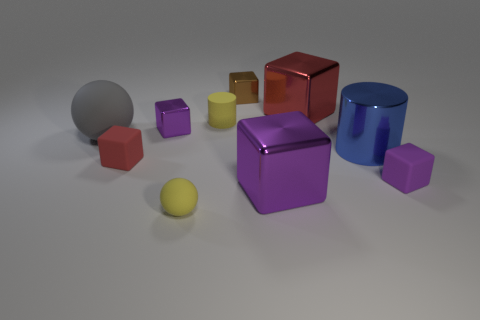What number of other things are there of the same size as the brown object?
Keep it short and to the point. 5. There is a small block that is both on the right side of the yellow rubber sphere and behind the purple matte thing; what material is it?
Ensure brevity in your answer.  Metal. Do the tiny purple thing that is behind the large gray rubber ball and the tiny object that is right of the big purple metallic block have the same shape?
Keep it short and to the point. Yes. Is there anything else that has the same material as the brown cube?
Give a very brief answer. Yes. There is a big metal thing that is to the right of the big metal cube to the right of the large thing in front of the big cylinder; what shape is it?
Offer a very short reply. Cylinder. How many other things are the same shape as the big red shiny object?
Offer a very short reply. 5. There is a rubber sphere that is the same size as the red shiny object; what color is it?
Make the answer very short. Gray. How many blocks are small yellow objects or large matte things?
Offer a terse response. 0. What number of small yellow matte cubes are there?
Offer a terse response. 0. Is the shape of the big purple object the same as the small thing that is on the right side of the large red metallic block?
Offer a terse response. Yes. 